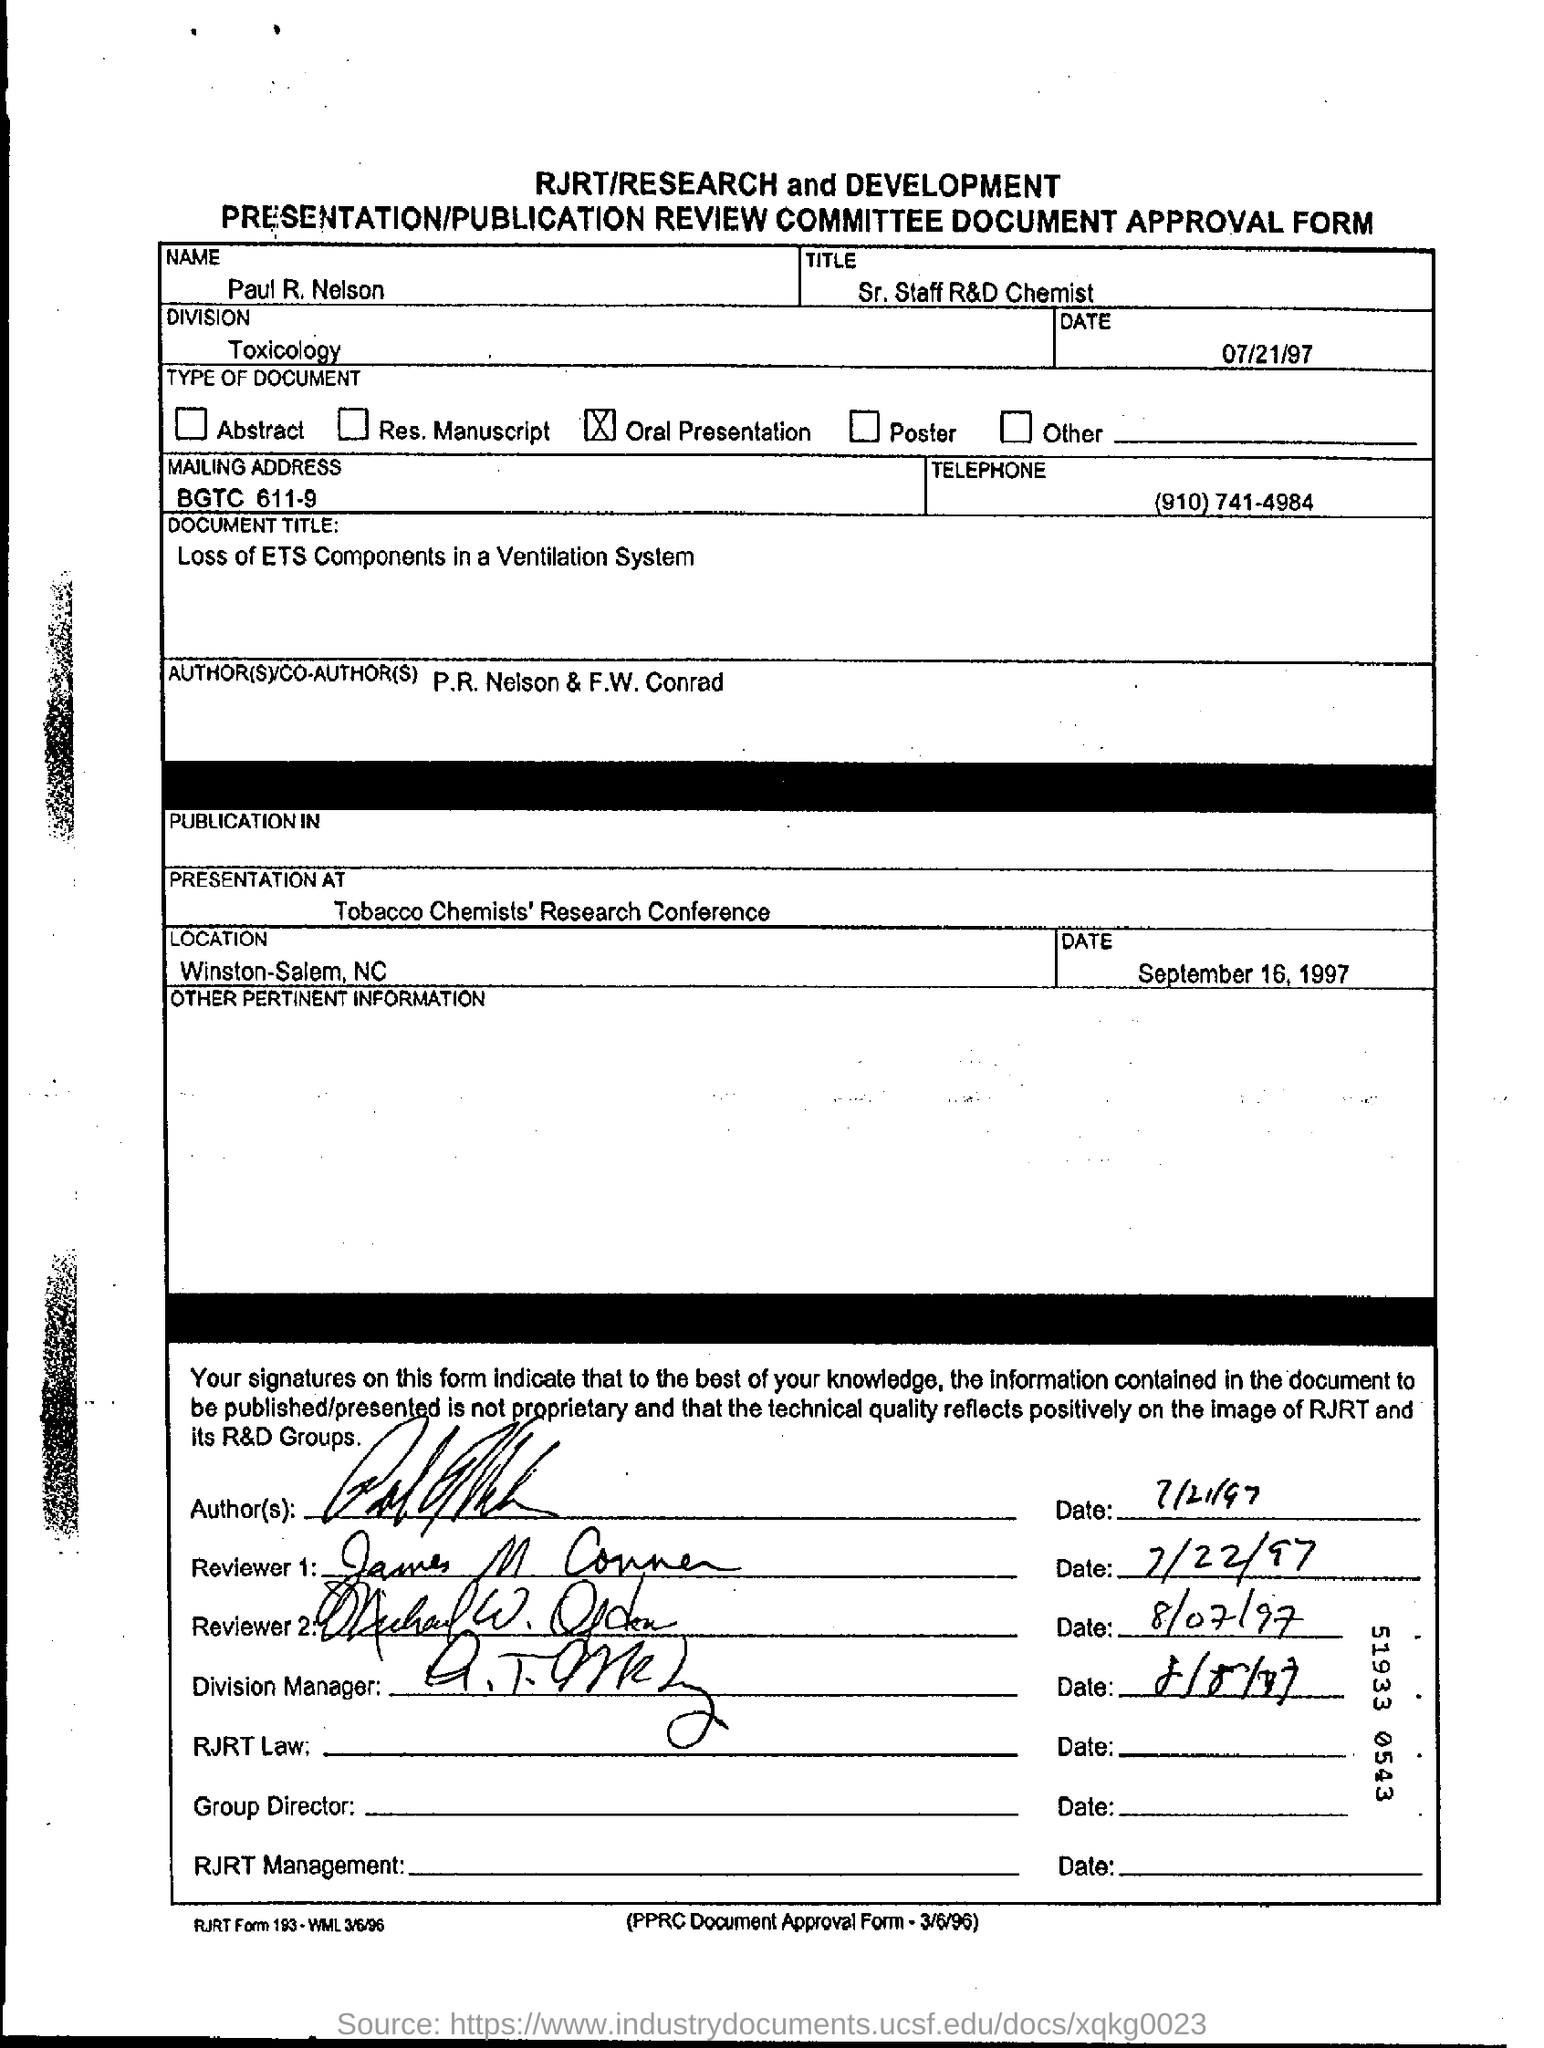Draw attention to some important aspects in this diagram. The title mentioned is Sr. Staff R&D Chemist. The mailing address is BGTC 611-9. The date mentioned is July 21, 1997. The telephone number is (910)741-4984. The presentation took place at the Tobacco Chemists' Research Conference. 